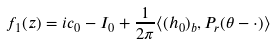<formula> <loc_0><loc_0><loc_500><loc_500>f _ { 1 } ( z ) = i c _ { 0 } - I _ { 0 } + \frac { 1 } { 2 \pi } \langle ( h _ { 0 } ) _ { b } , P _ { r } ( \theta - \cdot ) \rangle</formula> 